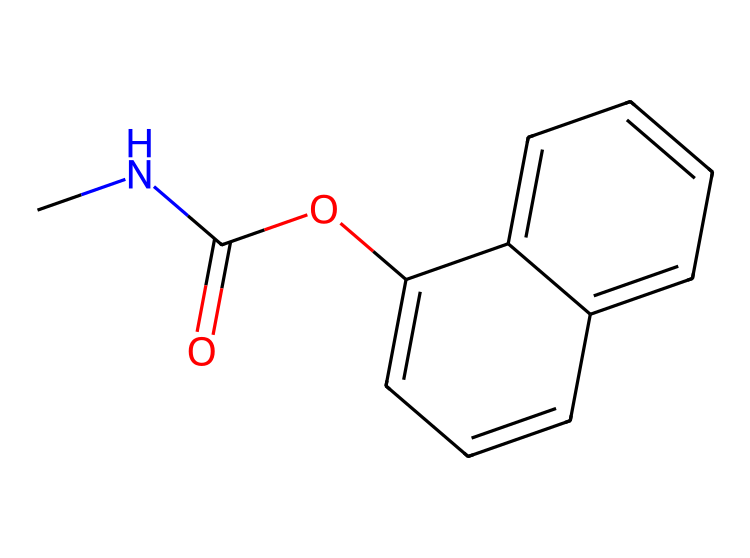What is the name of this chemical? The SMILES representation indicates this chemical is carbaryl, which is commonly known as an insecticide used for pest control.
Answer: carbaryl How many carbon atoms are in the structure? By analyzing the SMILES, we can see there are a total of 12 carbon atoms represented in the structure.
Answer: 12 What type of functional group is present in carbaryl? The presence of the carbonyl group (C=O) and the ether group (C-O-C) in the structure suggests it features both these functional groups.
Answer: carbonyl and ether How many rings are present in the structure? By inspecting the SMILES notation, the representation shows a bicyclic ring structure indicating there are two fused rings present in carbaryl.
Answer: 2 Which atom in this chemical is responsible for binding with insects? The nitrogen atom in the structure typically participates in the binding action with insect neurotransmitter receptors, making it crucial for the insecticidal activity of carbaryl.
Answer: nitrogen What is the primary use of this chemical type? Carbaryl, as a carbamate insecticide, is primarily used for controlling pests in agricultural and garden settings to protect crops.
Answer: pest control 